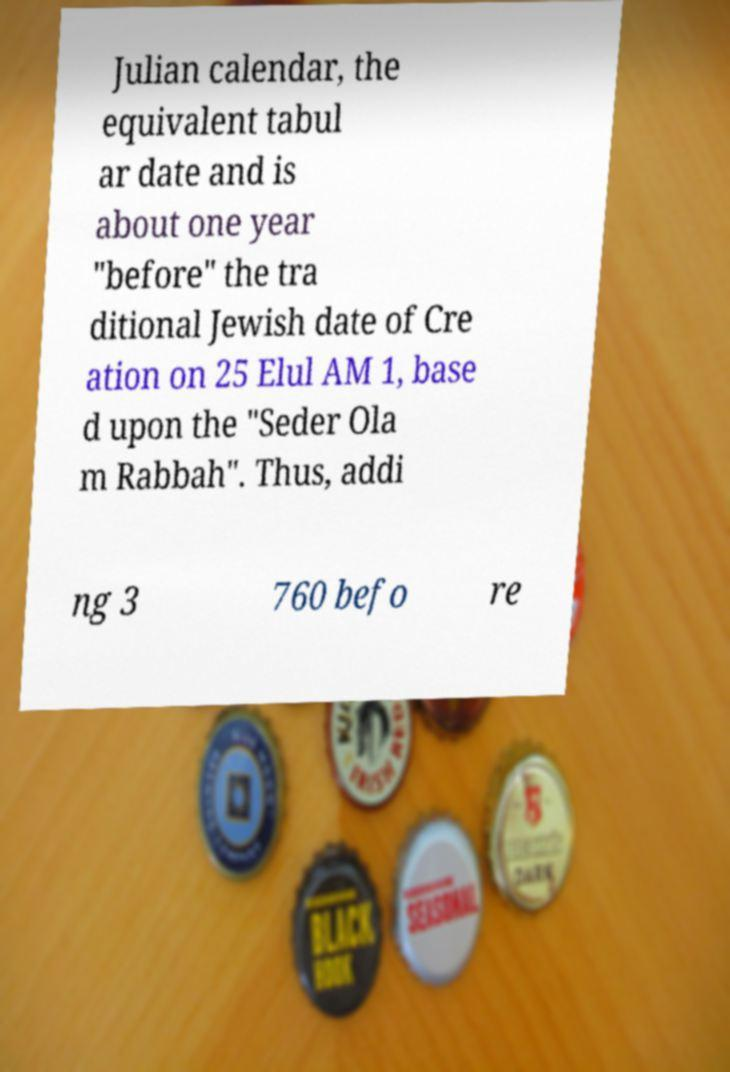Please identify and transcribe the text found in this image. Julian calendar, the equivalent tabul ar date and is about one year "before" the tra ditional Jewish date of Cre ation on 25 Elul AM 1, base d upon the "Seder Ola m Rabbah". Thus, addi ng 3 760 befo re 